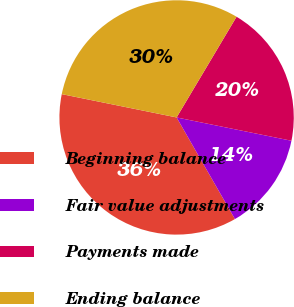Convert chart to OTSL. <chart><loc_0><loc_0><loc_500><loc_500><pie_chart><fcel>Beginning balance<fcel>Fair value adjustments<fcel>Payments made<fcel>Ending balance<nl><fcel>36.48%<fcel>13.52%<fcel>19.64%<fcel>30.36%<nl></chart> 